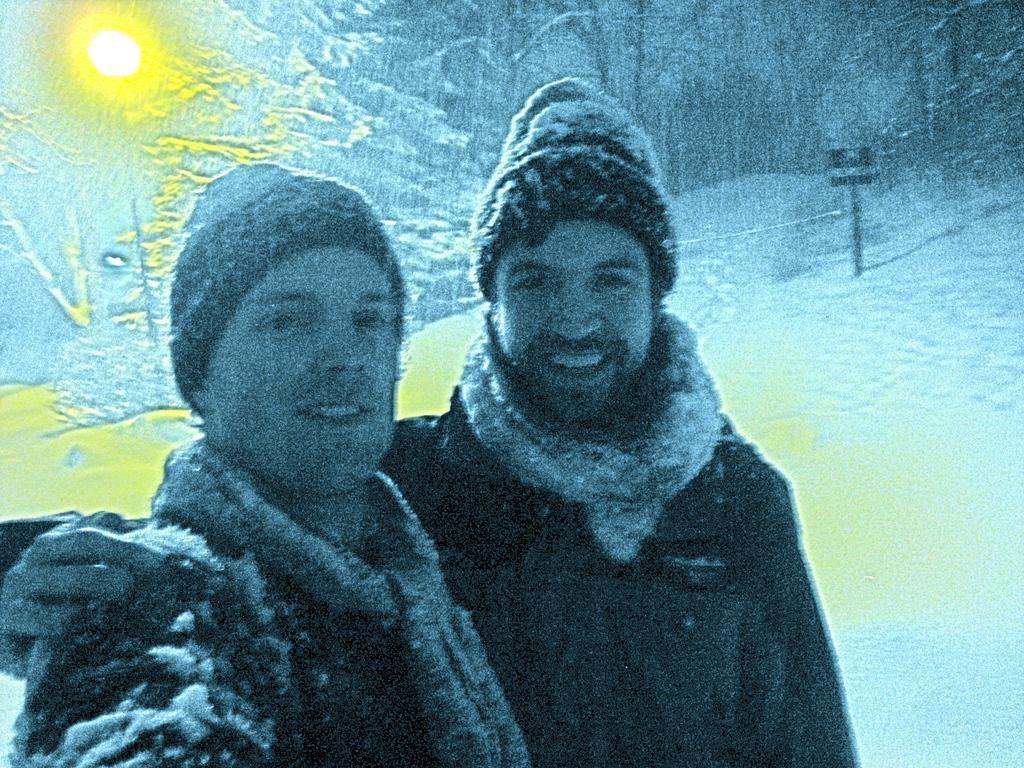Please provide a concise description of this image. This is an edited image. In this image I can see two people with the dresses. These people are standing on the snow. In the background I can see the boards and many trees. I can also see the light in the back. 